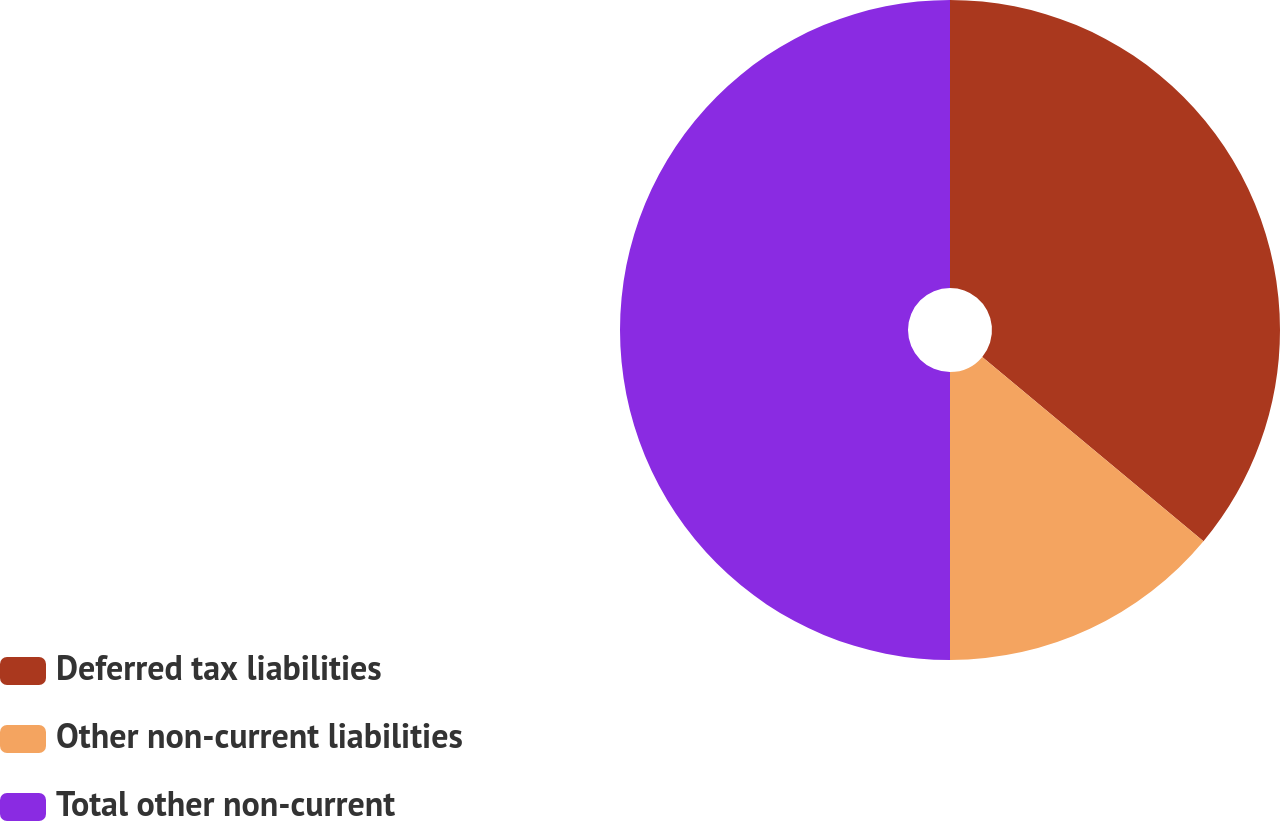Convert chart. <chart><loc_0><loc_0><loc_500><loc_500><pie_chart><fcel>Deferred tax liabilities<fcel>Other non-current liabilities<fcel>Total other non-current<nl><fcel>36.06%<fcel>13.94%<fcel>50.0%<nl></chart> 